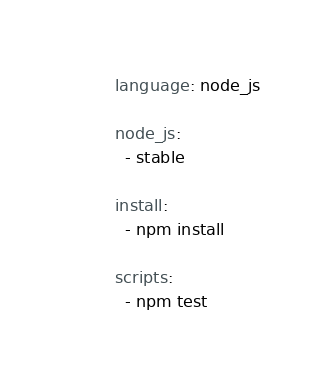<code> <loc_0><loc_0><loc_500><loc_500><_YAML_>language: node_js

node_js:
  - stable

install:
  - npm install
  
scripts:
  - npm test</code> 